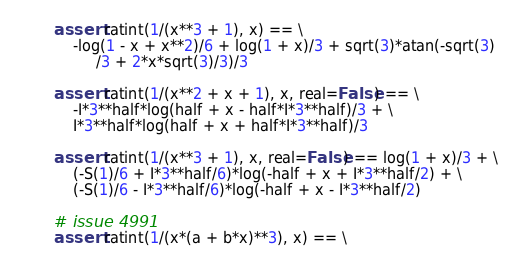<code> <loc_0><loc_0><loc_500><loc_500><_Python_>    assert ratint(1/(x**3 + 1), x) == \
        -log(1 - x + x**2)/6 + log(1 + x)/3 + sqrt(3)*atan(-sqrt(3)
             /3 + 2*x*sqrt(3)/3)/3

    assert ratint(1/(x**2 + x + 1), x, real=False) == \
        -I*3**half*log(half + x - half*I*3**half)/3 + \
        I*3**half*log(half + x + half*I*3**half)/3

    assert ratint(1/(x**3 + 1), x, real=False) == log(1 + x)/3 + \
        (-S(1)/6 + I*3**half/6)*log(-half + x + I*3**half/2) + \
        (-S(1)/6 - I*3**half/6)*log(-half + x - I*3**half/2)

    # issue 4991
    assert ratint(1/(x*(a + b*x)**3), x) == \</code> 